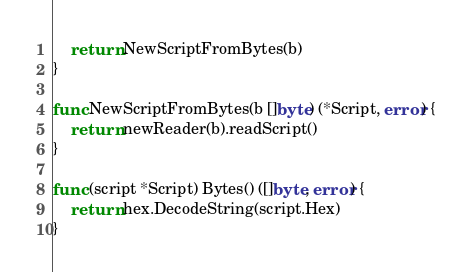<code> <loc_0><loc_0><loc_500><loc_500><_Go_>
	return NewScriptFromBytes(b)
}

func NewScriptFromBytes(b []byte) (*Script, error) {
	return newReader(b).readScript()
}

func (script *Script) Bytes() ([]byte, error) {
	return hex.DecodeString(script.Hex)
}
</code> 